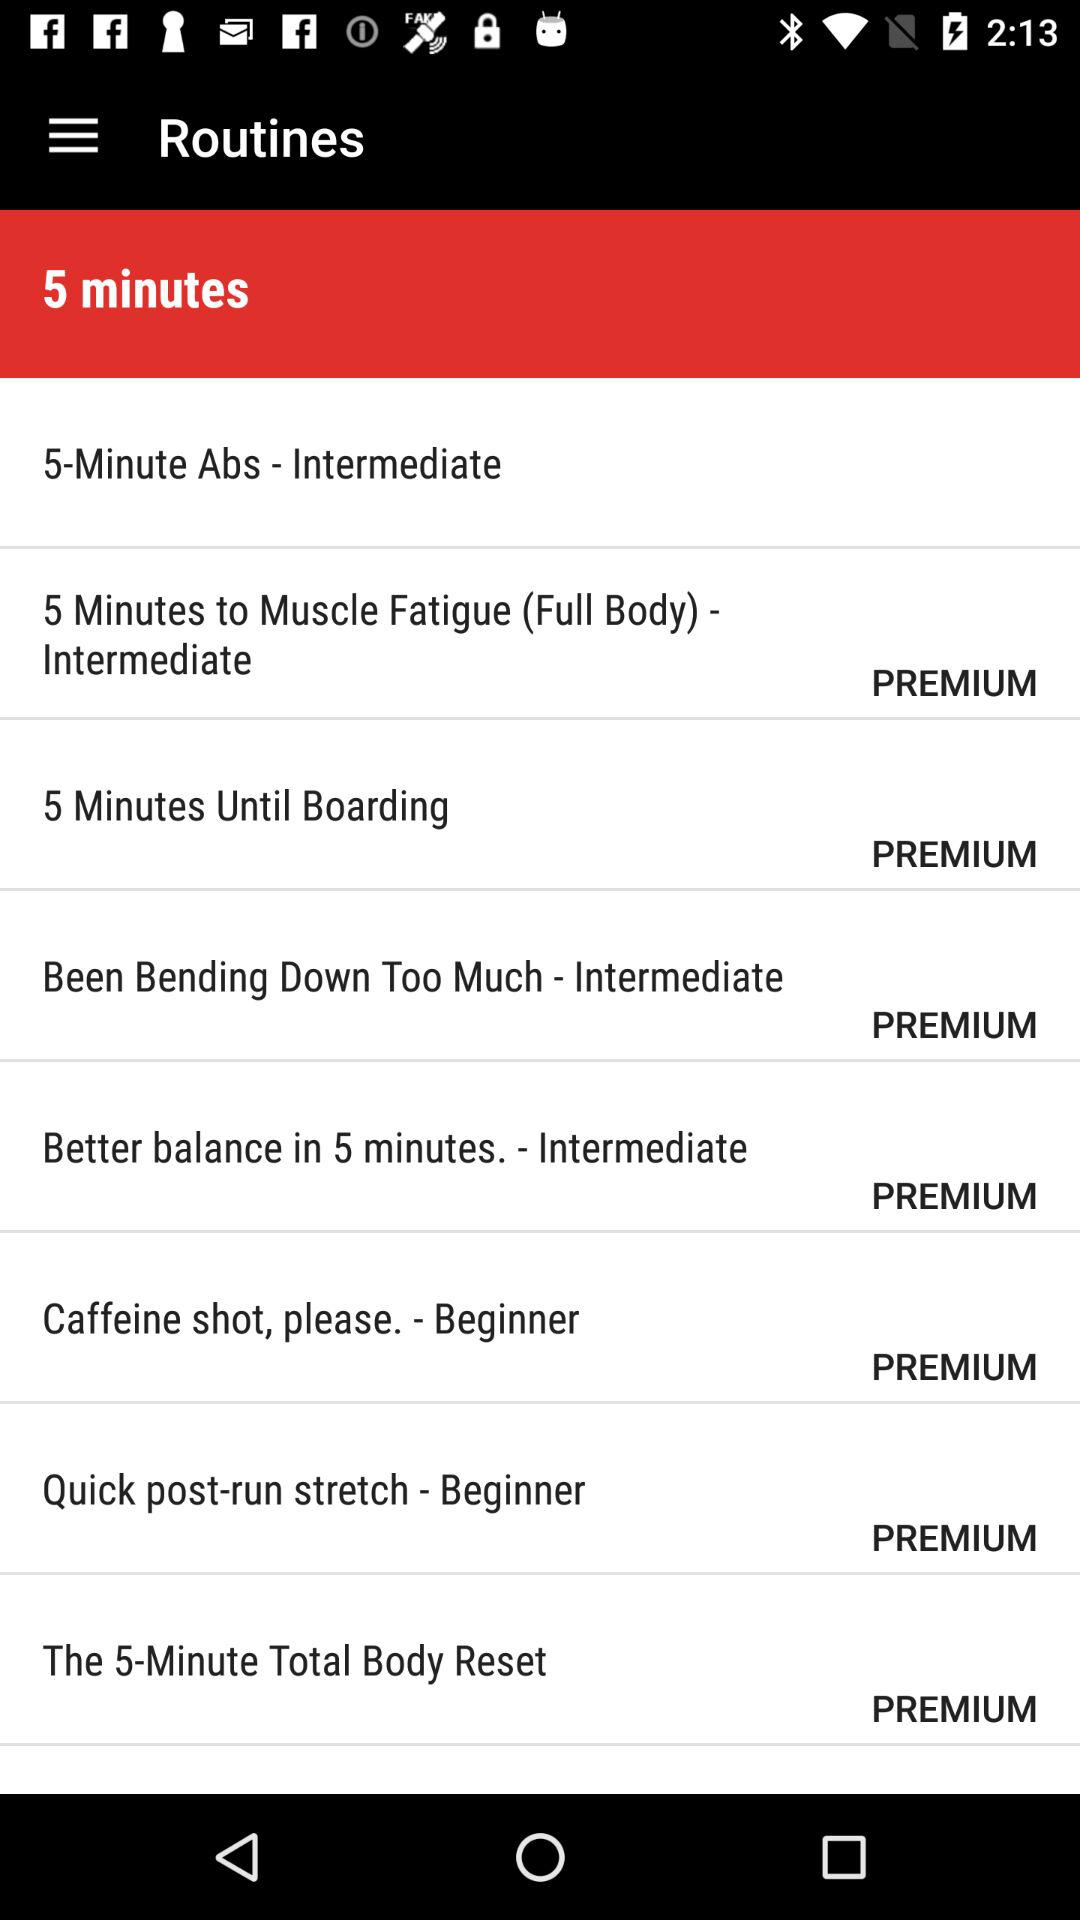Which is the level of "Been Bending Down Too Much"? The level of "Been Bending Down Too Much" is "Intermediate". 